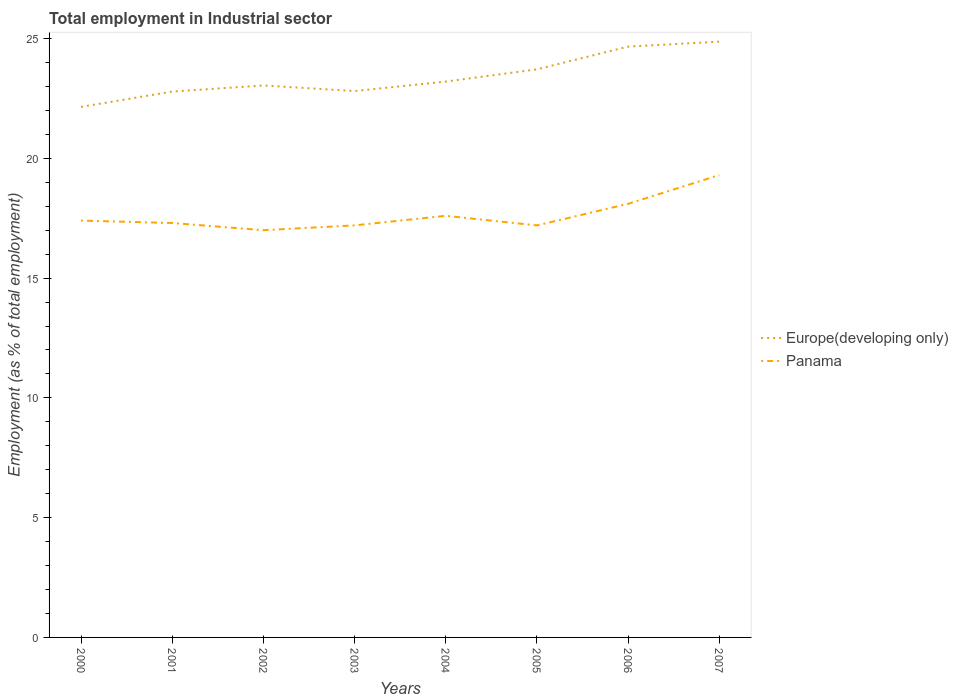How many different coloured lines are there?
Provide a short and direct response. 2. Does the line corresponding to Europe(developing only) intersect with the line corresponding to Panama?
Offer a very short reply. No. Is the number of lines equal to the number of legend labels?
Ensure brevity in your answer.  Yes. Across all years, what is the maximum employment in industrial sector in Panama?
Your answer should be very brief. 17. What is the total employment in industrial sector in Europe(developing only) in the graph?
Offer a terse response. -0.93. What is the difference between the highest and the second highest employment in industrial sector in Panama?
Your response must be concise. 2.3. What is the difference between the highest and the lowest employment in industrial sector in Europe(developing only)?
Ensure brevity in your answer.  3. How many lines are there?
Your response must be concise. 2. What is the difference between two consecutive major ticks on the Y-axis?
Your answer should be very brief. 5. Are the values on the major ticks of Y-axis written in scientific E-notation?
Provide a short and direct response. No. Does the graph contain any zero values?
Your answer should be compact. No. How are the legend labels stacked?
Provide a short and direct response. Vertical. What is the title of the graph?
Your answer should be very brief. Total employment in Industrial sector. What is the label or title of the Y-axis?
Provide a short and direct response. Employment (as % of total employment). What is the Employment (as % of total employment) in Europe(developing only) in 2000?
Give a very brief answer. 22.15. What is the Employment (as % of total employment) of Panama in 2000?
Give a very brief answer. 17.4. What is the Employment (as % of total employment) of Europe(developing only) in 2001?
Your answer should be compact. 22.79. What is the Employment (as % of total employment) in Panama in 2001?
Provide a short and direct response. 17.3. What is the Employment (as % of total employment) in Europe(developing only) in 2002?
Your answer should be compact. 23.04. What is the Employment (as % of total employment) of Europe(developing only) in 2003?
Keep it short and to the point. 22.81. What is the Employment (as % of total employment) in Panama in 2003?
Provide a short and direct response. 17.2. What is the Employment (as % of total employment) of Europe(developing only) in 2004?
Offer a terse response. 23.2. What is the Employment (as % of total employment) in Panama in 2004?
Offer a very short reply. 17.6. What is the Employment (as % of total employment) in Europe(developing only) in 2005?
Your answer should be very brief. 23.71. What is the Employment (as % of total employment) of Panama in 2005?
Make the answer very short. 17.2. What is the Employment (as % of total employment) in Europe(developing only) in 2006?
Provide a short and direct response. 24.66. What is the Employment (as % of total employment) in Panama in 2006?
Give a very brief answer. 18.1. What is the Employment (as % of total employment) of Europe(developing only) in 2007?
Your response must be concise. 24.87. What is the Employment (as % of total employment) of Panama in 2007?
Your answer should be compact. 19.3. Across all years, what is the maximum Employment (as % of total employment) of Europe(developing only)?
Keep it short and to the point. 24.87. Across all years, what is the maximum Employment (as % of total employment) in Panama?
Your answer should be compact. 19.3. Across all years, what is the minimum Employment (as % of total employment) of Europe(developing only)?
Provide a short and direct response. 22.15. What is the total Employment (as % of total employment) in Europe(developing only) in the graph?
Your response must be concise. 187.23. What is the total Employment (as % of total employment) in Panama in the graph?
Ensure brevity in your answer.  141.1. What is the difference between the Employment (as % of total employment) of Europe(developing only) in 2000 and that in 2001?
Provide a succinct answer. -0.64. What is the difference between the Employment (as % of total employment) in Europe(developing only) in 2000 and that in 2002?
Ensure brevity in your answer.  -0.9. What is the difference between the Employment (as % of total employment) in Panama in 2000 and that in 2002?
Provide a short and direct response. 0.4. What is the difference between the Employment (as % of total employment) in Europe(developing only) in 2000 and that in 2003?
Provide a succinct answer. -0.66. What is the difference between the Employment (as % of total employment) of Europe(developing only) in 2000 and that in 2004?
Make the answer very short. -1.06. What is the difference between the Employment (as % of total employment) in Europe(developing only) in 2000 and that in 2005?
Your answer should be compact. -1.57. What is the difference between the Employment (as % of total employment) in Europe(developing only) in 2000 and that in 2006?
Your answer should be very brief. -2.52. What is the difference between the Employment (as % of total employment) in Europe(developing only) in 2000 and that in 2007?
Offer a terse response. -2.72. What is the difference between the Employment (as % of total employment) in Panama in 2000 and that in 2007?
Provide a succinct answer. -1.9. What is the difference between the Employment (as % of total employment) of Europe(developing only) in 2001 and that in 2002?
Your answer should be very brief. -0.26. What is the difference between the Employment (as % of total employment) in Europe(developing only) in 2001 and that in 2003?
Ensure brevity in your answer.  -0.02. What is the difference between the Employment (as % of total employment) of Panama in 2001 and that in 2003?
Keep it short and to the point. 0.1. What is the difference between the Employment (as % of total employment) in Europe(developing only) in 2001 and that in 2004?
Provide a short and direct response. -0.42. What is the difference between the Employment (as % of total employment) in Panama in 2001 and that in 2004?
Ensure brevity in your answer.  -0.3. What is the difference between the Employment (as % of total employment) of Europe(developing only) in 2001 and that in 2005?
Ensure brevity in your answer.  -0.93. What is the difference between the Employment (as % of total employment) in Panama in 2001 and that in 2005?
Your answer should be compact. 0.1. What is the difference between the Employment (as % of total employment) in Europe(developing only) in 2001 and that in 2006?
Keep it short and to the point. -1.88. What is the difference between the Employment (as % of total employment) of Panama in 2001 and that in 2006?
Make the answer very short. -0.8. What is the difference between the Employment (as % of total employment) of Europe(developing only) in 2001 and that in 2007?
Your response must be concise. -2.08. What is the difference between the Employment (as % of total employment) of Panama in 2001 and that in 2007?
Ensure brevity in your answer.  -2. What is the difference between the Employment (as % of total employment) in Europe(developing only) in 2002 and that in 2003?
Offer a very short reply. 0.23. What is the difference between the Employment (as % of total employment) in Panama in 2002 and that in 2003?
Your response must be concise. -0.2. What is the difference between the Employment (as % of total employment) in Europe(developing only) in 2002 and that in 2004?
Your response must be concise. -0.16. What is the difference between the Employment (as % of total employment) in Panama in 2002 and that in 2004?
Offer a very short reply. -0.6. What is the difference between the Employment (as % of total employment) in Europe(developing only) in 2002 and that in 2005?
Provide a succinct answer. -0.67. What is the difference between the Employment (as % of total employment) in Panama in 2002 and that in 2005?
Your answer should be very brief. -0.2. What is the difference between the Employment (as % of total employment) of Europe(developing only) in 2002 and that in 2006?
Give a very brief answer. -1.62. What is the difference between the Employment (as % of total employment) in Panama in 2002 and that in 2006?
Your response must be concise. -1.1. What is the difference between the Employment (as % of total employment) of Europe(developing only) in 2002 and that in 2007?
Provide a succinct answer. -1.83. What is the difference between the Employment (as % of total employment) in Panama in 2002 and that in 2007?
Offer a terse response. -2.3. What is the difference between the Employment (as % of total employment) in Europe(developing only) in 2003 and that in 2004?
Give a very brief answer. -0.4. What is the difference between the Employment (as % of total employment) of Panama in 2003 and that in 2004?
Your answer should be very brief. -0.4. What is the difference between the Employment (as % of total employment) in Europe(developing only) in 2003 and that in 2005?
Offer a very short reply. -0.91. What is the difference between the Employment (as % of total employment) in Panama in 2003 and that in 2005?
Ensure brevity in your answer.  0. What is the difference between the Employment (as % of total employment) in Europe(developing only) in 2003 and that in 2006?
Make the answer very short. -1.86. What is the difference between the Employment (as % of total employment) in Europe(developing only) in 2003 and that in 2007?
Provide a succinct answer. -2.06. What is the difference between the Employment (as % of total employment) of Panama in 2003 and that in 2007?
Your answer should be compact. -2.1. What is the difference between the Employment (as % of total employment) of Europe(developing only) in 2004 and that in 2005?
Provide a short and direct response. -0.51. What is the difference between the Employment (as % of total employment) in Europe(developing only) in 2004 and that in 2006?
Your answer should be compact. -1.46. What is the difference between the Employment (as % of total employment) in Europe(developing only) in 2004 and that in 2007?
Ensure brevity in your answer.  -1.67. What is the difference between the Employment (as % of total employment) in Europe(developing only) in 2005 and that in 2006?
Give a very brief answer. -0.95. What is the difference between the Employment (as % of total employment) in Europe(developing only) in 2005 and that in 2007?
Your answer should be very brief. -1.16. What is the difference between the Employment (as % of total employment) in Europe(developing only) in 2006 and that in 2007?
Keep it short and to the point. -0.21. What is the difference between the Employment (as % of total employment) in Panama in 2006 and that in 2007?
Provide a short and direct response. -1.2. What is the difference between the Employment (as % of total employment) of Europe(developing only) in 2000 and the Employment (as % of total employment) of Panama in 2001?
Your answer should be very brief. 4.85. What is the difference between the Employment (as % of total employment) in Europe(developing only) in 2000 and the Employment (as % of total employment) in Panama in 2002?
Provide a short and direct response. 5.15. What is the difference between the Employment (as % of total employment) of Europe(developing only) in 2000 and the Employment (as % of total employment) of Panama in 2003?
Make the answer very short. 4.95. What is the difference between the Employment (as % of total employment) in Europe(developing only) in 2000 and the Employment (as % of total employment) in Panama in 2004?
Your answer should be compact. 4.55. What is the difference between the Employment (as % of total employment) of Europe(developing only) in 2000 and the Employment (as % of total employment) of Panama in 2005?
Keep it short and to the point. 4.95. What is the difference between the Employment (as % of total employment) of Europe(developing only) in 2000 and the Employment (as % of total employment) of Panama in 2006?
Give a very brief answer. 4.05. What is the difference between the Employment (as % of total employment) of Europe(developing only) in 2000 and the Employment (as % of total employment) of Panama in 2007?
Ensure brevity in your answer.  2.85. What is the difference between the Employment (as % of total employment) in Europe(developing only) in 2001 and the Employment (as % of total employment) in Panama in 2002?
Your answer should be very brief. 5.79. What is the difference between the Employment (as % of total employment) in Europe(developing only) in 2001 and the Employment (as % of total employment) in Panama in 2003?
Offer a very short reply. 5.59. What is the difference between the Employment (as % of total employment) in Europe(developing only) in 2001 and the Employment (as % of total employment) in Panama in 2004?
Make the answer very short. 5.19. What is the difference between the Employment (as % of total employment) of Europe(developing only) in 2001 and the Employment (as % of total employment) of Panama in 2005?
Your answer should be very brief. 5.59. What is the difference between the Employment (as % of total employment) in Europe(developing only) in 2001 and the Employment (as % of total employment) in Panama in 2006?
Make the answer very short. 4.69. What is the difference between the Employment (as % of total employment) of Europe(developing only) in 2001 and the Employment (as % of total employment) of Panama in 2007?
Offer a terse response. 3.49. What is the difference between the Employment (as % of total employment) of Europe(developing only) in 2002 and the Employment (as % of total employment) of Panama in 2003?
Provide a short and direct response. 5.84. What is the difference between the Employment (as % of total employment) of Europe(developing only) in 2002 and the Employment (as % of total employment) of Panama in 2004?
Offer a very short reply. 5.44. What is the difference between the Employment (as % of total employment) in Europe(developing only) in 2002 and the Employment (as % of total employment) in Panama in 2005?
Your answer should be very brief. 5.84. What is the difference between the Employment (as % of total employment) of Europe(developing only) in 2002 and the Employment (as % of total employment) of Panama in 2006?
Your answer should be compact. 4.94. What is the difference between the Employment (as % of total employment) of Europe(developing only) in 2002 and the Employment (as % of total employment) of Panama in 2007?
Make the answer very short. 3.74. What is the difference between the Employment (as % of total employment) of Europe(developing only) in 2003 and the Employment (as % of total employment) of Panama in 2004?
Your answer should be very brief. 5.21. What is the difference between the Employment (as % of total employment) of Europe(developing only) in 2003 and the Employment (as % of total employment) of Panama in 2005?
Your answer should be very brief. 5.61. What is the difference between the Employment (as % of total employment) in Europe(developing only) in 2003 and the Employment (as % of total employment) in Panama in 2006?
Make the answer very short. 4.71. What is the difference between the Employment (as % of total employment) in Europe(developing only) in 2003 and the Employment (as % of total employment) in Panama in 2007?
Your answer should be compact. 3.51. What is the difference between the Employment (as % of total employment) of Europe(developing only) in 2004 and the Employment (as % of total employment) of Panama in 2005?
Offer a terse response. 6. What is the difference between the Employment (as % of total employment) of Europe(developing only) in 2004 and the Employment (as % of total employment) of Panama in 2006?
Offer a terse response. 5.1. What is the difference between the Employment (as % of total employment) in Europe(developing only) in 2004 and the Employment (as % of total employment) in Panama in 2007?
Provide a short and direct response. 3.9. What is the difference between the Employment (as % of total employment) of Europe(developing only) in 2005 and the Employment (as % of total employment) of Panama in 2006?
Your response must be concise. 5.61. What is the difference between the Employment (as % of total employment) of Europe(developing only) in 2005 and the Employment (as % of total employment) of Panama in 2007?
Offer a terse response. 4.41. What is the difference between the Employment (as % of total employment) of Europe(developing only) in 2006 and the Employment (as % of total employment) of Panama in 2007?
Your answer should be compact. 5.36. What is the average Employment (as % of total employment) of Europe(developing only) per year?
Give a very brief answer. 23.4. What is the average Employment (as % of total employment) of Panama per year?
Keep it short and to the point. 17.64. In the year 2000, what is the difference between the Employment (as % of total employment) in Europe(developing only) and Employment (as % of total employment) in Panama?
Give a very brief answer. 4.75. In the year 2001, what is the difference between the Employment (as % of total employment) in Europe(developing only) and Employment (as % of total employment) in Panama?
Ensure brevity in your answer.  5.49. In the year 2002, what is the difference between the Employment (as % of total employment) in Europe(developing only) and Employment (as % of total employment) in Panama?
Offer a very short reply. 6.04. In the year 2003, what is the difference between the Employment (as % of total employment) of Europe(developing only) and Employment (as % of total employment) of Panama?
Your answer should be very brief. 5.61. In the year 2004, what is the difference between the Employment (as % of total employment) in Europe(developing only) and Employment (as % of total employment) in Panama?
Offer a terse response. 5.6. In the year 2005, what is the difference between the Employment (as % of total employment) in Europe(developing only) and Employment (as % of total employment) in Panama?
Your answer should be compact. 6.51. In the year 2006, what is the difference between the Employment (as % of total employment) in Europe(developing only) and Employment (as % of total employment) in Panama?
Provide a succinct answer. 6.56. In the year 2007, what is the difference between the Employment (as % of total employment) of Europe(developing only) and Employment (as % of total employment) of Panama?
Provide a short and direct response. 5.57. What is the ratio of the Employment (as % of total employment) in Europe(developing only) in 2000 to that in 2001?
Provide a short and direct response. 0.97. What is the ratio of the Employment (as % of total employment) of Panama in 2000 to that in 2001?
Make the answer very short. 1.01. What is the ratio of the Employment (as % of total employment) in Europe(developing only) in 2000 to that in 2002?
Offer a terse response. 0.96. What is the ratio of the Employment (as % of total employment) in Panama in 2000 to that in 2002?
Your answer should be very brief. 1.02. What is the ratio of the Employment (as % of total employment) of Panama in 2000 to that in 2003?
Provide a short and direct response. 1.01. What is the ratio of the Employment (as % of total employment) of Europe(developing only) in 2000 to that in 2004?
Keep it short and to the point. 0.95. What is the ratio of the Employment (as % of total employment) of Panama in 2000 to that in 2004?
Keep it short and to the point. 0.99. What is the ratio of the Employment (as % of total employment) in Europe(developing only) in 2000 to that in 2005?
Provide a succinct answer. 0.93. What is the ratio of the Employment (as % of total employment) of Panama in 2000 to that in 2005?
Give a very brief answer. 1.01. What is the ratio of the Employment (as % of total employment) of Europe(developing only) in 2000 to that in 2006?
Give a very brief answer. 0.9. What is the ratio of the Employment (as % of total employment) of Panama in 2000 to that in 2006?
Keep it short and to the point. 0.96. What is the ratio of the Employment (as % of total employment) of Europe(developing only) in 2000 to that in 2007?
Give a very brief answer. 0.89. What is the ratio of the Employment (as % of total employment) of Panama in 2000 to that in 2007?
Provide a short and direct response. 0.9. What is the ratio of the Employment (as % of total employment) in Europe(developing only) in 2001 to that in 2002?
Offer a very short reply. 0.99. What is the ratio of the Employment (as % of total employment) of Panama in 2001 to that in 2002?
Give a very brief answer. 1.02. What is the ratio of the Employment (as % of total employment) in Europe(developing only) in 2001 to that in 2004?
Make the answer very short. 0.98. What is the ratio of the Employment (as % of total employment) in Europe(developing only) in 2001 to that in 2005?
Your response must be concise. 0.96. What is the ratio of the Employment (as % of total employment) of Panama in 2001 to that in 2005?
Ensure brevity in your answer.  1.01. What is the ratio of the Employment (as % of total employment) in Europe(developing only) in 2001 to that in 2006?
Offer a very short reply. 0.92. What is the ratio of the Employment (as % of total employment) of Panama in 2001 to that in 2006?
Provide a short and direct response. 0.96. What is the ratio of the Employment (as % of total employment) in Europe(developing only) in 2001 to that in 2007?
Provide a short and direct response. 0.92. What is the ratio of the Employment (as % of total employment) in Panama in 2001 to that in 2007?
Make the answer very short. 0.9. What is the ratio of the Employment (as % of total employment) of Europe(developing only) in 2002 to that in 2003?
Give a very brief answer. 1.01. What is the ratio of the Employment (as % of total employment) in Panama in 2002 to that in 2003?
Your answer should be compact. 0.99. What is the ratio of the Employment (as % of total employment) of Europe(developing only) in 2002 to that in 2004?
Offer a very short reply. 0.99. What is the ratio of the Employment (as % of total employment) in Panama in 2002 to that in 2004?
Provide a short and direct response. 0.97. What is the ratio of the Employment (as % of total employment) in Europe(developing only) in 2002 to that in 2005?
Provide a short and direct response. 0.97. What is the ratio of the Employment (as % of total employment) of Panama in 2002 to that in 2005?
Offer a very short reply. 0.99. What is the ratio of the Employment (as % of total employment) in Europe(developing only) in 2002 to that in 2006?
Offer a terse response. 0.93. What is the ratio of the Employment (as % of total employment) of Panama in 2002 to that in 2006?
Your answer should be compact. 0.94. What is the ratio of the Employment (as % of total employment) of Europe(developing only) in 2002 to that in 2007?
Ensure brevity in your answer.  0.93. What is the ratio of the Employment (as % of total employment) in Panama in 2002 to that in 2007?
Provide a succinct answer. 0.88. What is the ratio of the Employment (as % of total employment) of Europe(developing only) in 2003 to that in 2004?
Make the answer very short. 0.98. What is the ratio of the Employment (as % of total employment) in Panama in 2003 to that in 2004?
Provide a short and direct response. 0.98. What is the ratio of the Employment (as % of total employment) of Europe(developing only) in 2003 to that in 2005?
Your response must be concise. 0.96. What is the ratio of the Employment (as % of total employment) of Europe(developing only) in 2003 to that in 2006?
Provide a short and direct response. 0.92. What is the ratio of the Employment (as % of total employment) in Panama in 2003 to that in 2006?
Provide a short and direct response. 0.95. What is the ratio of the Employment (as % of total employment) of Europe(developing only) in 2003 to that in 2007?
Provide a short and direct response. 0.92. What is the ratio of the Employment (as % of total employment) in Panama in 2003 to that in 2007?
Ensure brevity in your answer.  0.89. What is the ratio of the Employment (as % of total employment) in Europe(developing only) in 2004 to that in 2005?
Offer a very short reply. 0.98. What is the ratio of the Employment (as % of total employment) of Panama in 2004 to that in 2005?
Your response must be concise. 1.02. What is the ratio of the Employment (as % of total employment) of Europe(developing only) in 2004 to that in 2006?
Provide a succinct answer. 0.94. What is the ratio of the Employment (as % of total employment) in Panama in 2004 to that in 2006?
Give a very brief answer. 0.97. What is the ratio of the Employment (as % of total employment) of Europe(developing only) in 2004 to that in 2007?
Provide a short and direct response. 0.93. What is the ratio of the Employment (as % of total employment) in Panama in 2004 to that in 2007?
Keep it short and to the point. 0.91. What is the ratio of the Employment (as % of total employment) in Europe(developing only) in 2005 to that in 2006?
Your answer should be very brief. 0.96. What is the ratio of the Employment (as % of total employment) of Panama in 2005 to that in 2006?
Offer a very short reply. 0.95. What is the ratio of the Employment (as % of total employment) in Europe(developing only) in 2005 to that in 2007?
Make the answer very short. 0.95. What is the ratio of the Employment (as % of total employment) of Panama in 2005 to that in 2007?
Give a very brief answer. 0.89. What is the ratio of the Employment (as % of total employment) in Panama in 2006 to that in 2007?
Offer a terse response. 0.94. What is the difference between the highest and the second highest Employment (as % of total employment) of Europe(developing only)?
Your answer should be very brief. 0.21. What is the difference between the highest and the lowest Employment (as % of total employment) of Europe(developing only)?
Provide a succinct answer. 2.72. What is the difference between the highest and the lowest Employment (as % of total employment) of Panama?
Make the answer very short. 2.3. 